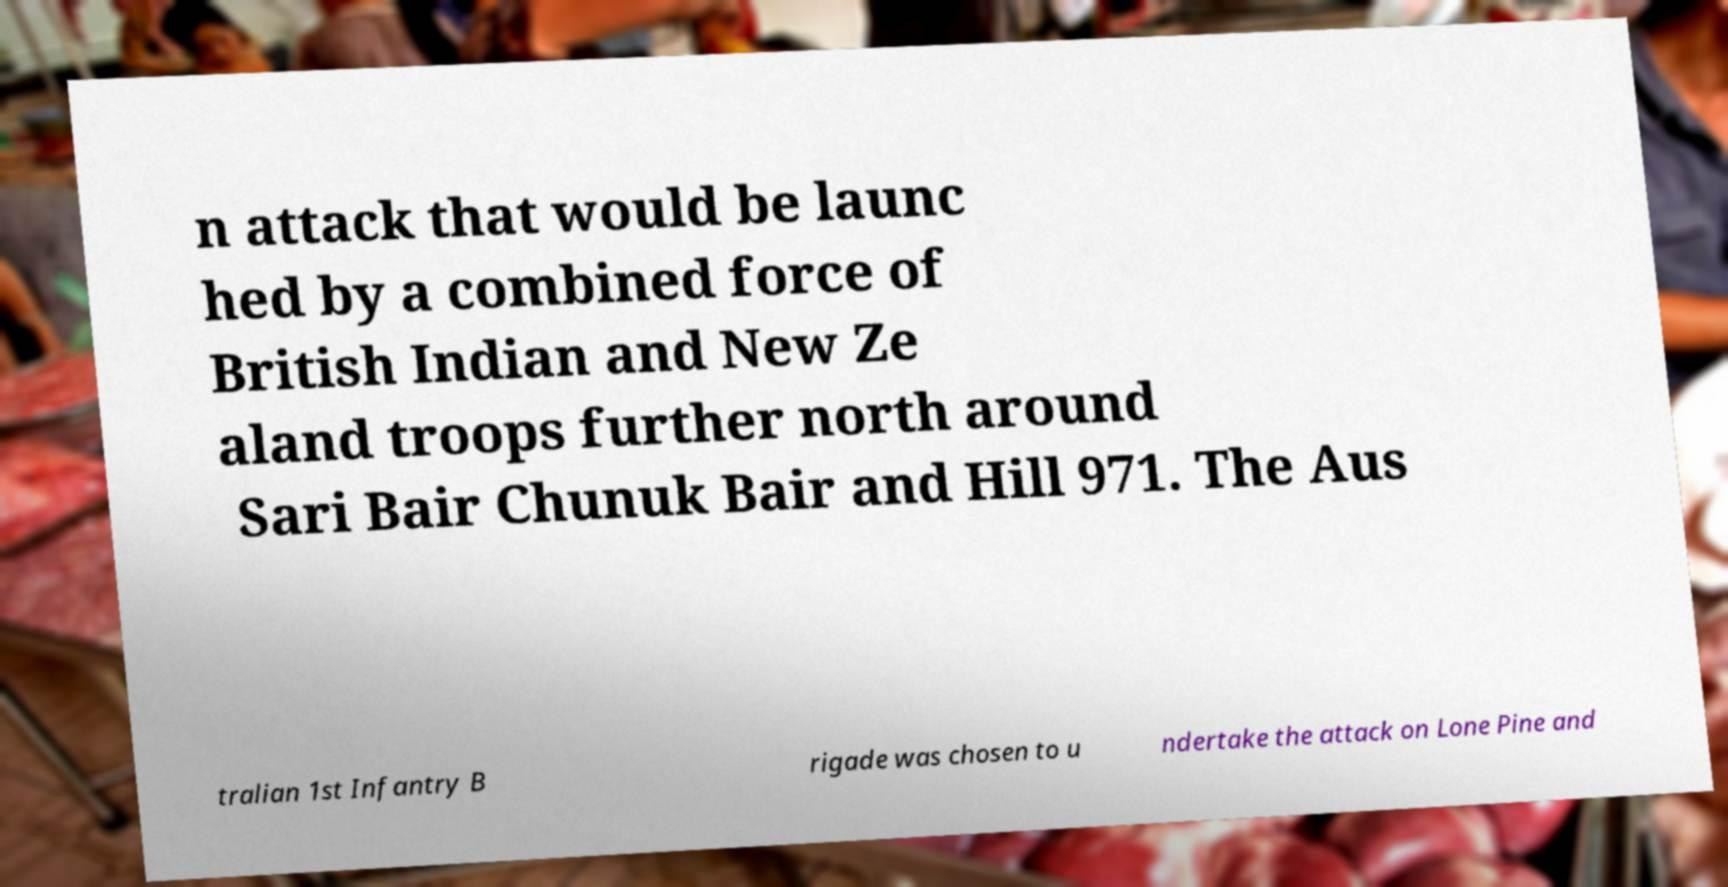Could you extract and type out the text from this image? n attack that would be launc hed by a combined force of British Indian and New Ze aland troops further north around Sari Bair Chunuk Bair and Hill 971. The Aus tralian 1st Infantry B rigade was chosen to u ndertake the attack on Lone Pine and 